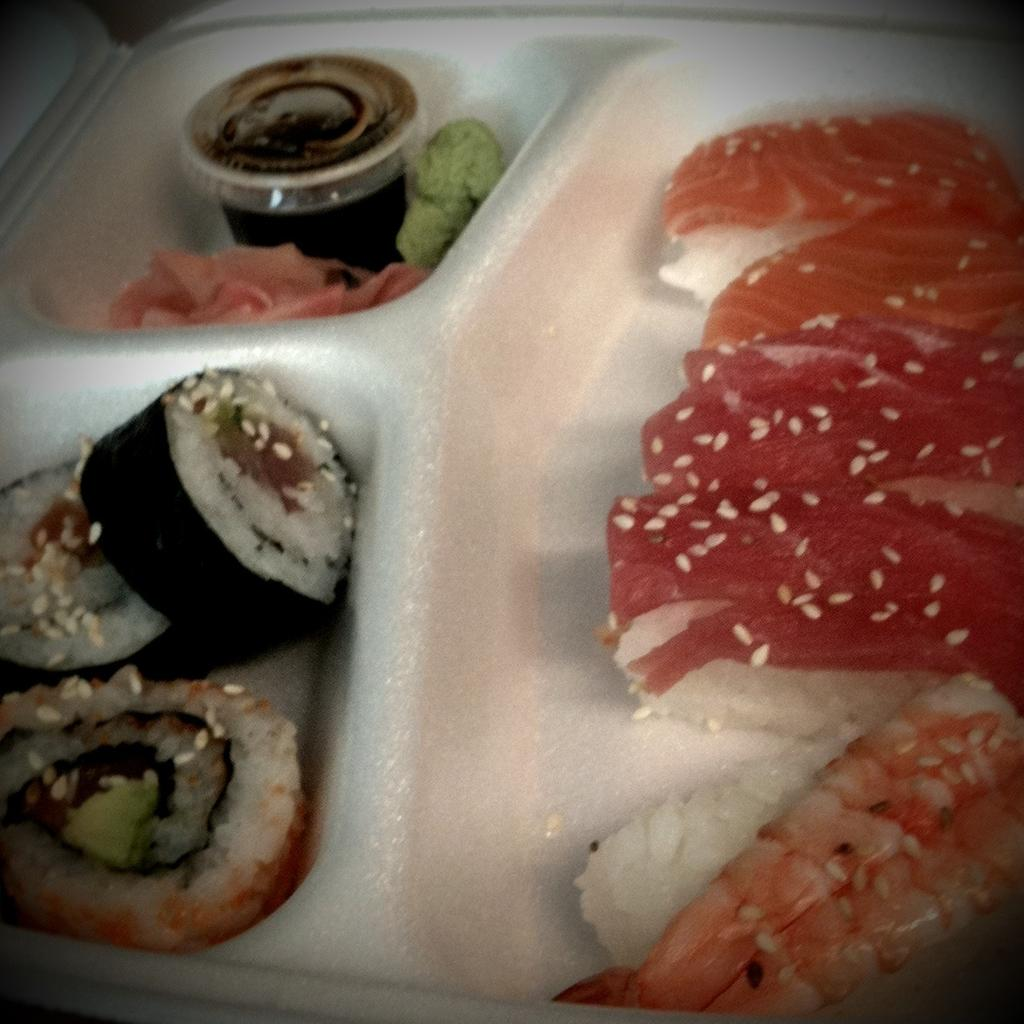What can be seen in the image? There are food items in the image. How are the food items arranged in the image? The food items are in a plate. What type of magic is being performed with the food items in the image? There is no magic or any indication of a performance in the image; it simply shows food items in a plate. 